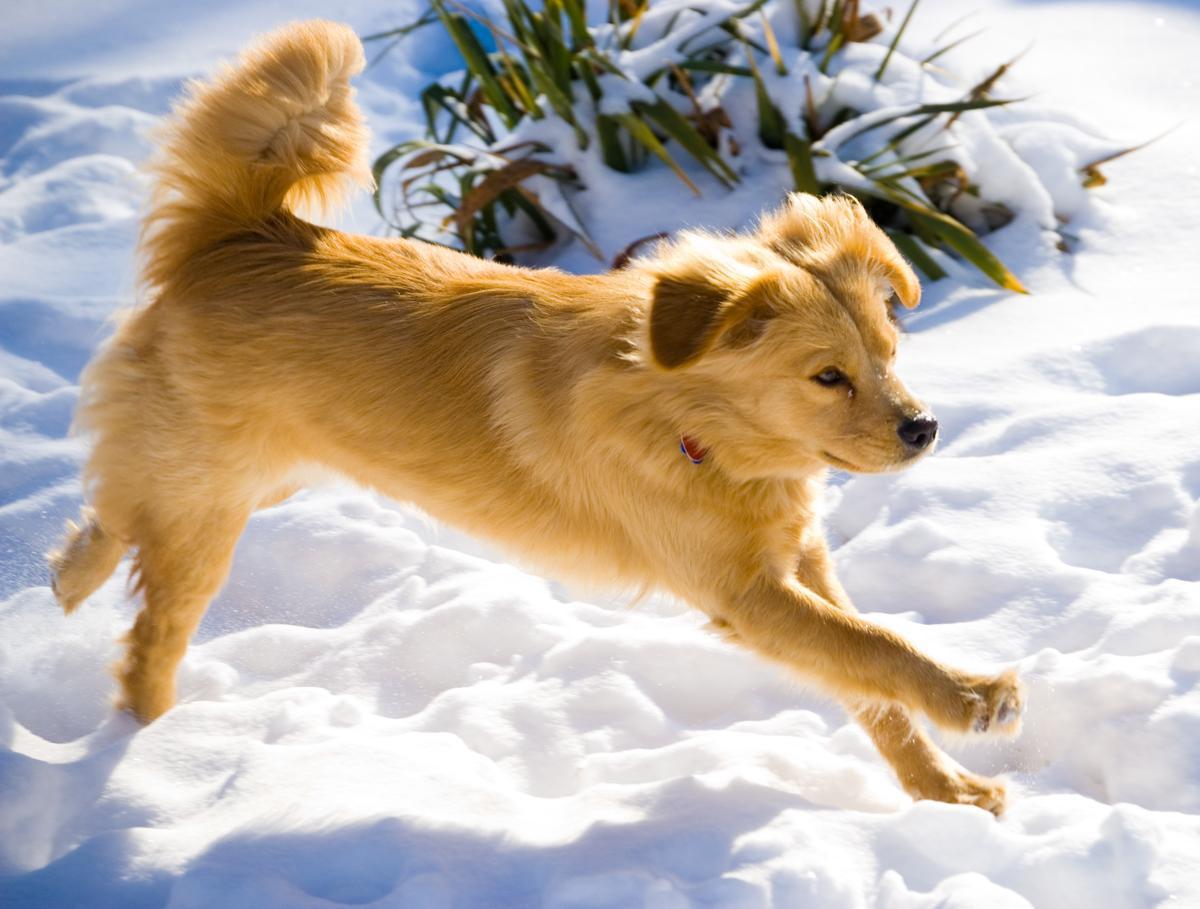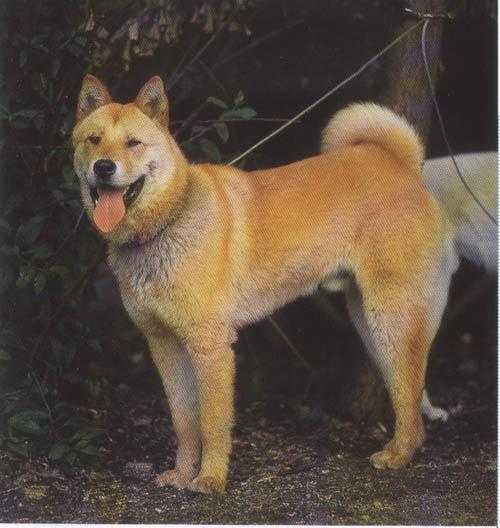The first image is the image on the left, the second image is the image on the right. Considering the images on both sides, is "The dog on the right is clearly a much smaller, shorter animal than the dog on the left." valid? Answer yes or no. No. 